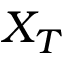<formula> <loc_0><loc_0><loc_500><loc_500>X _ { T }</formula> 